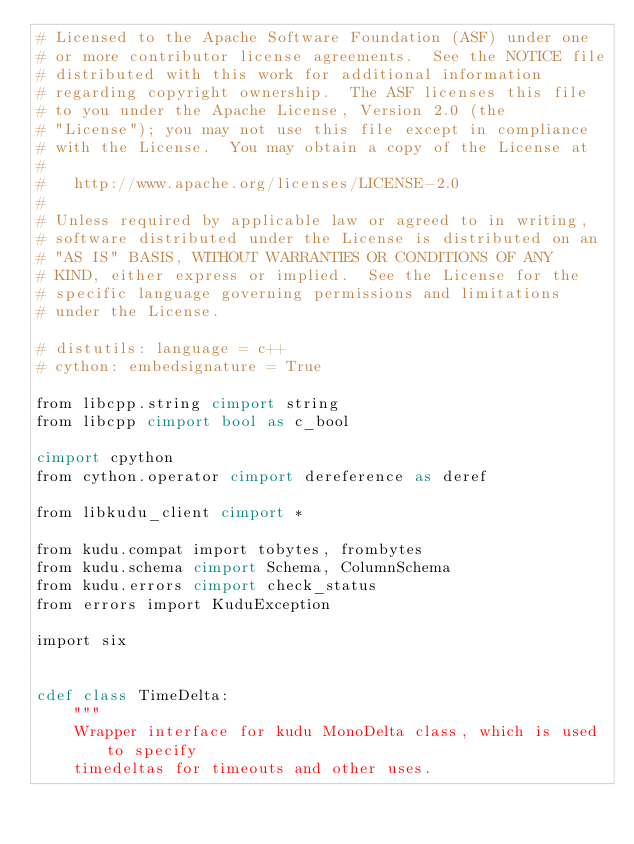Convert code to text. <code><loc_0><loc_0><loc_500><loc_500><_Cython_># Licensed to the Apache Software Foundation (ASF) under one
# or more contributor license agreements.  See the NOTICE file
# distributed with this work for additional information
# regarding copyright ownership.  The ASF licenses this file
# to you under the Apache License, Version 2.0 (the
# "License"); you may not use this file except in compliance
# with the License.  You may obtain a copy of the License at
#
#   http://www.apache.org/licenses/LICENSE-2.0
#
# Unless required by applicable law or agreed to in writing,
# software distributed under the License is distributed on an
# "AS IS" BASIS, WITHOUT WARRANTIES OR CONDITIONS OF ANY
# KIND, either express or implied.  See the License for the
# specific language governing permissions and limitations
# under the License.

# distutils: language = c++
# cython: embedsignature = True

from libcpp.string cimport string
from libcpp cimport bool as c_bool

cimport cpython
from cython.operator cimport dereference as deref

from libkudu_client cimport *

from kudu.compat import tobytes, frombytes
from kudu.schema cimport Schema, ColumnSchema
from kudu.errors cimport check_status
from errors import KuduException

import six


cdef class TimeDelta:
    """
    Wrapper interface for kudu MonoDelta class, which is used to specify
    timedeltas for timeouts and other uses.</code> 